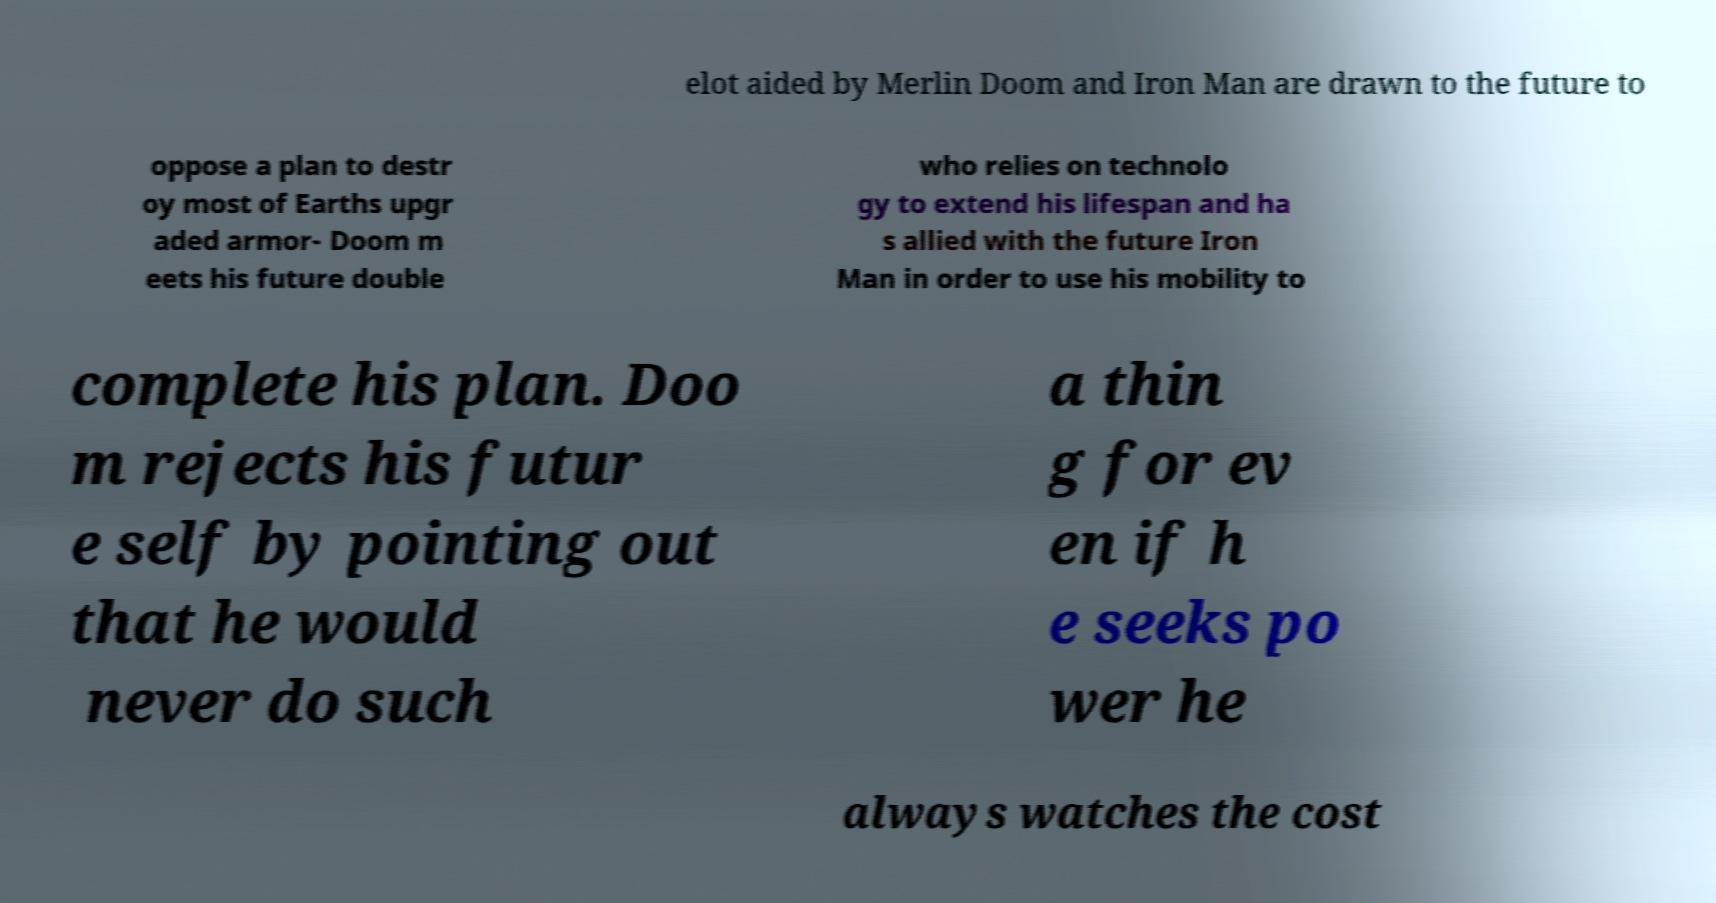Could you extract and type out the text from this image? elot aided by Merlin Doom and Iron Man are drawn to the future to oppose a plan to destr oy most of Earths upgr aded armor- Doom m eets his future double who relies on technolo gy to extend his lifespan and ha s allied with the future Iron Man in order to use his mobility to complete his plan. Doo m rejects his futur e self by pointing out that he would never do such a thin g for ev en if h e seeks po wer he always watches the cost 